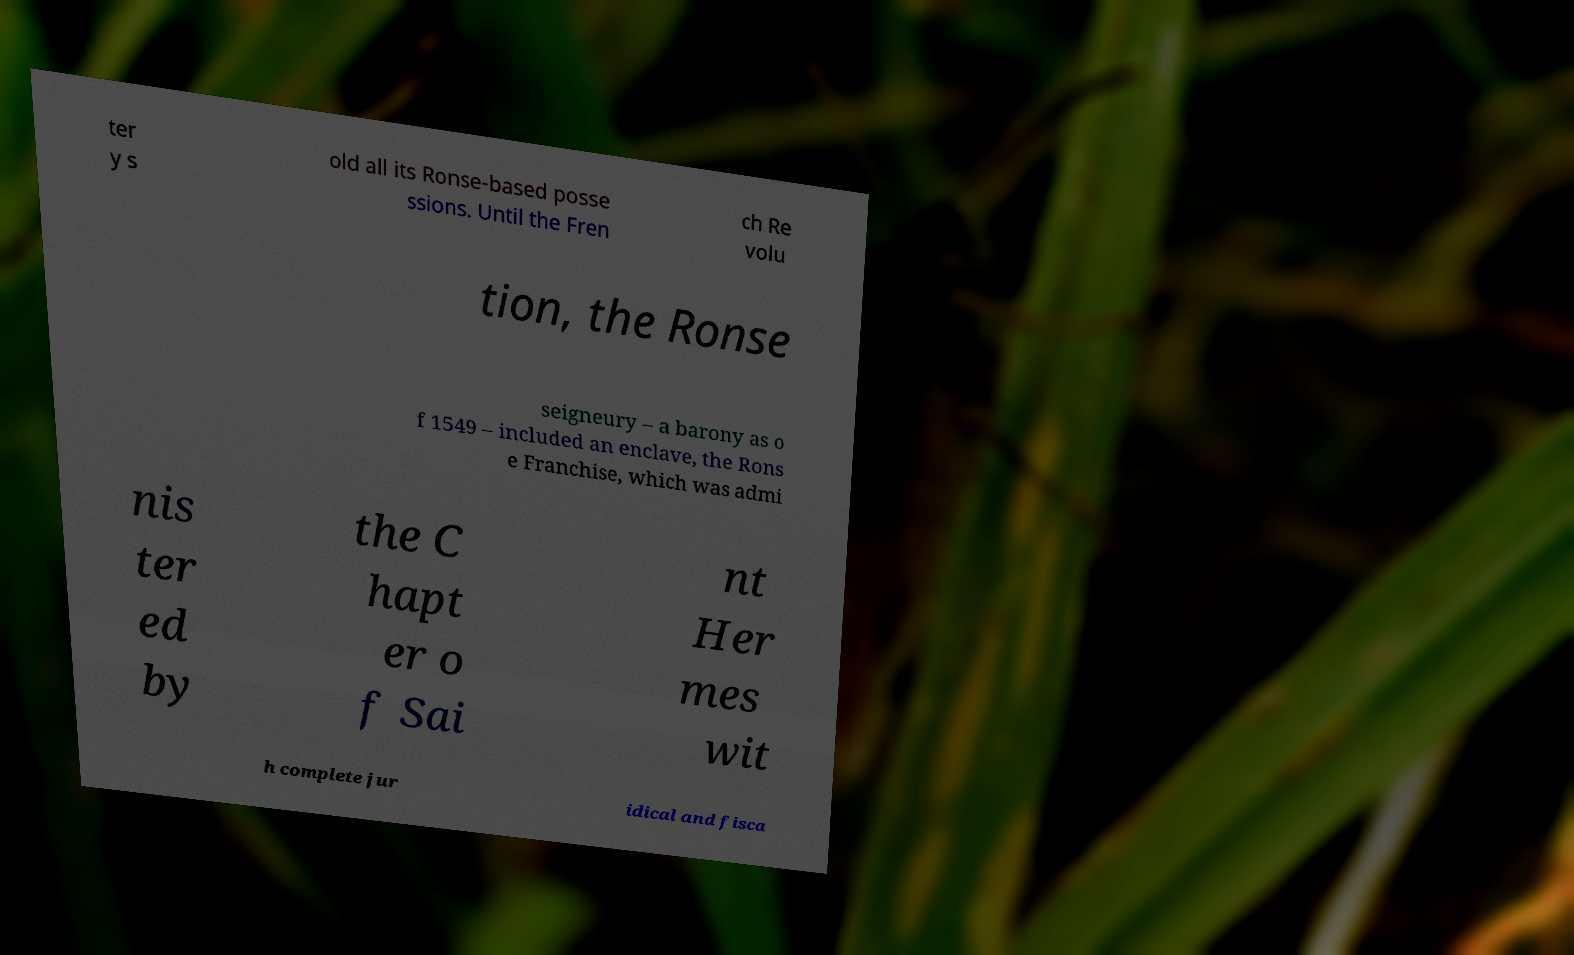I need the written content from this picture converted into text. Can you do that? ter y s old all its Ronse-based posse ssions. Until the Fren ch Re volu tion, the Ronse seigneury – a barony as o f 1549 – included an enclave, the Rons e Franchise, which was admi nis ter ed by the C hapt er o f Sai nt Her mes wit h complete jur idical and fisca 